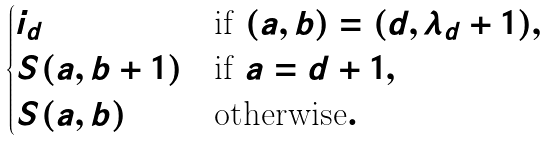<formula> <loc_0><loc_0><loc_500><loc_500>\begin{cases} i _ { d } & \text {if } ( a , b ) = ( d , \lambda _ { d } + 1 ) , \\ S ( a , b + 1 ) & \text {if } a = d + 1 , \\ S ( a , b ) & \text {otherwise} . \end{cases}</formula> 